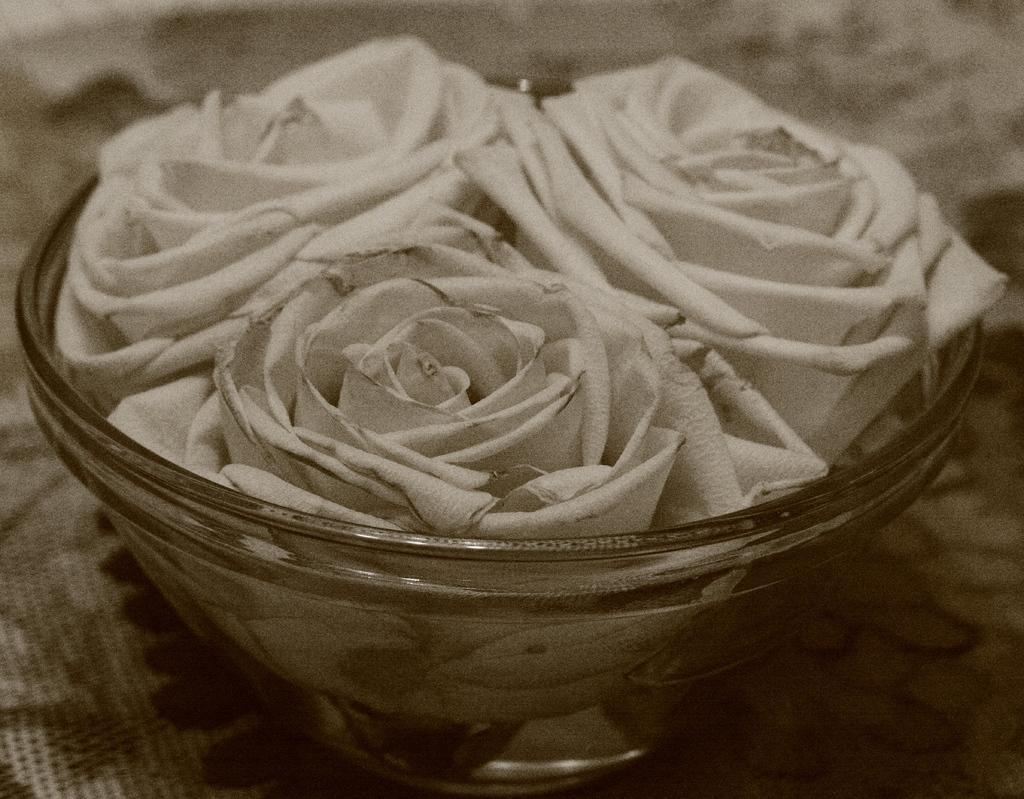Could you give a brief overview of what you see in this image? In this picture we can see white roses in a glass bowl. This bowl is kept on the table. 